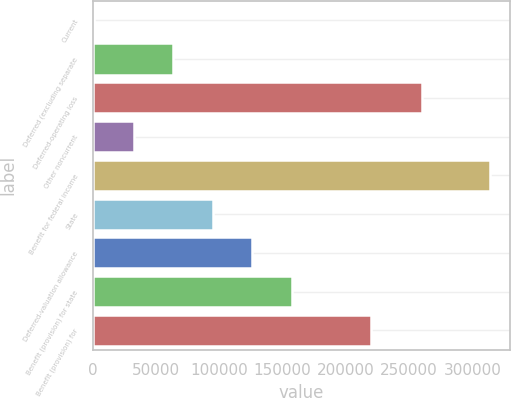Convert chart. <chart><loc_0><loc_0><loc_500><loc_500><bar_chart><fcel>Current<fcel>Deferred (excluding separate<fcel>Deferred-operating loss<fcel>Other noncurrent<fcel>Benefit for federal income<fcel>State<fcel>Deferred-valuation allowance<fcel>Benefit (provision) for state<fcel>Benefit (provision) for<nl><fcel>1237<fcel>63727.8<fcel>260167<fcel>32482.4<fcel>313691<fcel>94973.2<fcel>126219<fcel>157464<fcel>219955<nl></chart> 